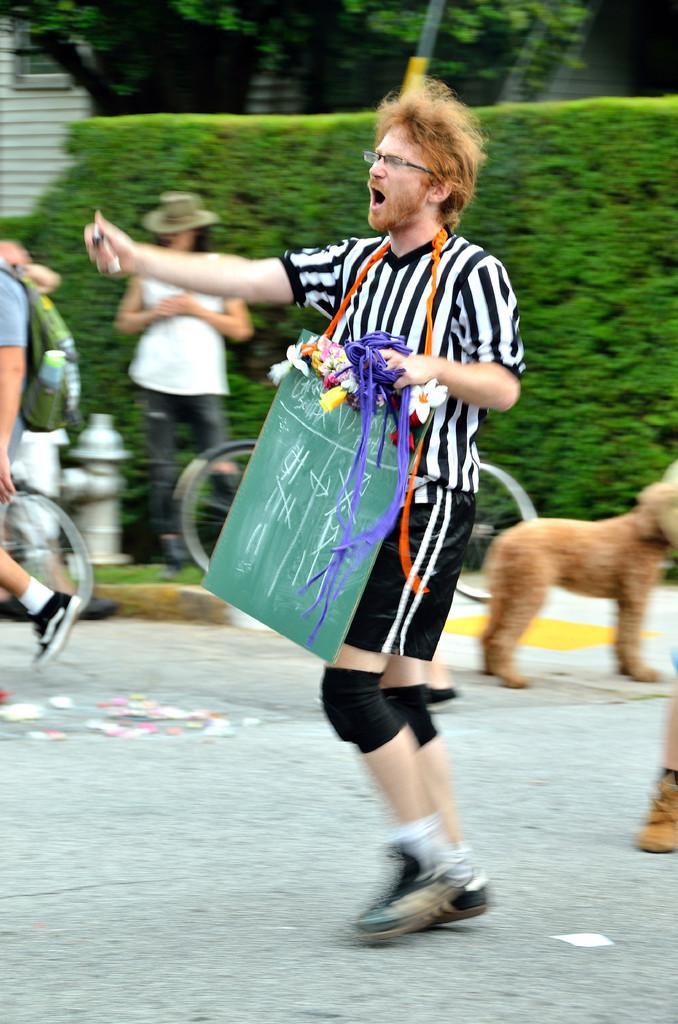Please provide a concise description of this image. In this image I can see a person wearing a black color t-shirt , standing on the road and holding a carry bag and some other objects , his mouth is open and back side of him I can see bushes ,in front of bushes I can see a person standing on the floor and I can see bi-cycle , fire extinguisher beside that person , on the right side I can see a dog and on the left side I can see a person walking on the road. 